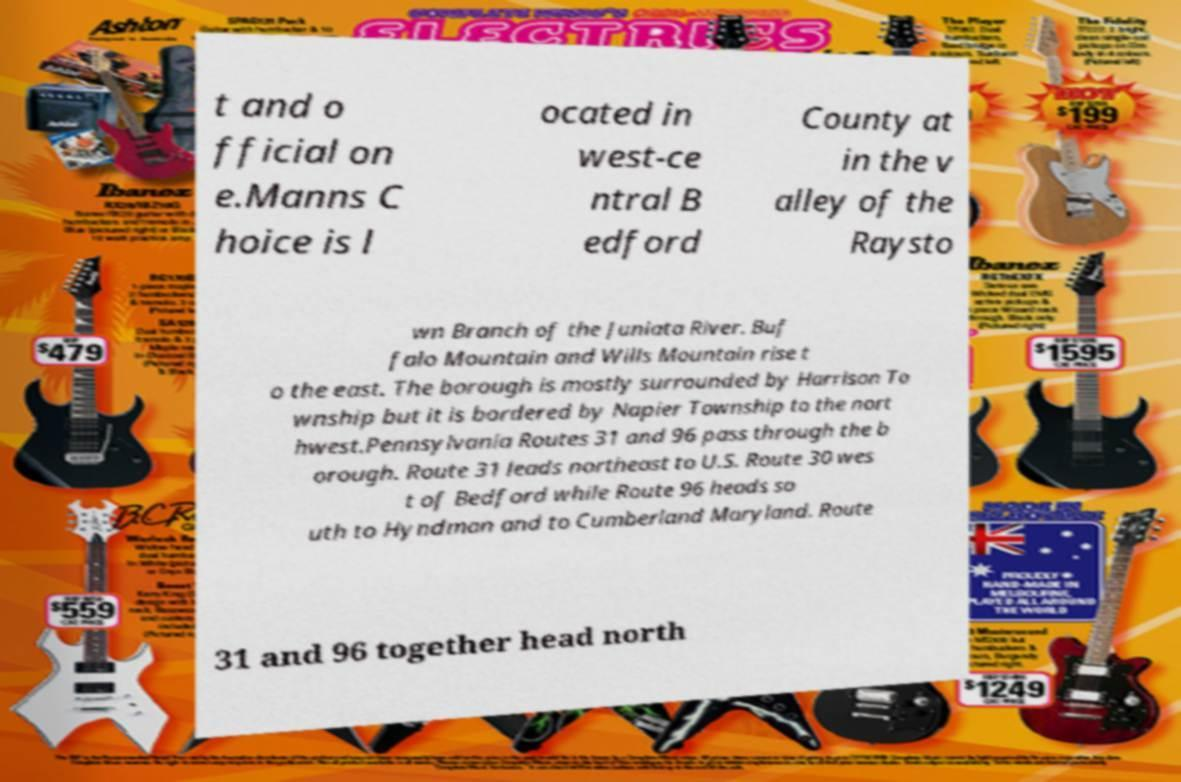For documentation purposes, I need the text within this image transcribed. Could you provide that? t and o fficial on e.Manns C hoice is l ocated in west-ce ntral B edford County at in the v alley of the Raysto wn Branch of the Juniata River. Buf falo Mountain and Wills Mountain rise t o the east. The borough is mostly surrounded by Harrison To wnship but it is bordered by Napier Township to the nort hwest.Pennsylvania Routes 31 and 96 pass through the b orough. Route 31 leads northeast to U.S. Route 30 wes t of Bedford while Route 96 heads so uth to Hyndman and to Cumberland Maryland. Route 31 and 96 together head north 